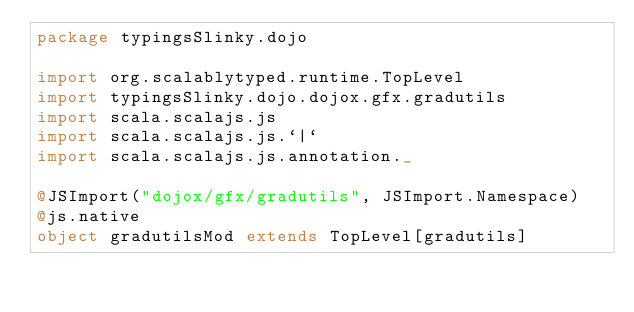Convert code to text. <code><loc_0><loc_0><loc_500><loc_500><_Scala_>package typingsSlinky.dojo

import org.scalablytyped.runtime.TopLevel
import typingsSlinky.dojo.dojox.gfx.gradutils
import scala.scalajs.js
import scala.scalajs.js.`|`
import scala.scalajs.js.annotation._

@JSImport("dojox/gfx/gradutils", JSImport.Namespace)
@js.native
object gradutilsMod extends TopLevel[gradutils]

</code> 